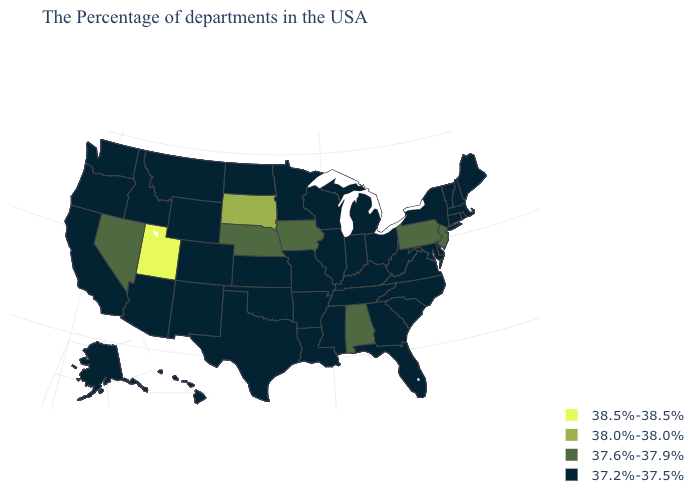Name the states that have a value in the range 37.6%-37.9%?
Be succinct. New Jersey, Pennsylvania, Alabama, Iowa, Nebraska, Nevada. What is the value of Florida?
Keep it brief. 37.2%-37.5%. Among the states that border Minnesota , which have the highest value?
Give a very brief answer. South Dakota. What is the lowest value in the MidWest?
Answer briefly. 37.2%-37.5%. Name the states that have a value in the range 37.2%-37.5%?
Write a very short answer. Maine, Massachusetts, Rhode Island, New Hampshire, Vermont, Connecticut, New York, Delaware, Maryland, Virginia, North Carolina, South Carolina, West Virginia, Ohio, Florida, Georgia, Michigan, Kentucky, Indiana, Tennessee, Wisconsin, Illinois, Mississippi, Louisiana, Missouri, Arkansas, Minnesota, Kansas, Oklahoma, Texas, North Dakota, Wyoming, Colorado, New Mexico, Montana, Arizona, Idaho, California, Washington, Oregon, Alaska, Hawaii. What is the lowest value in the Northeast?
Quick response, please. 37.2%-37.5%. Does Texas have a higher value than Vermont?
Concise answer only. No. Does Wisconsin have the highest value in the USA?
Keep it brief. No. Among the states that border Alabama , which have the highest value?
Short answer required. Florida, Georgia, Tennessee, Mississippi. Among the states that border Maine , which have the highest value?
Answer briefly. New Hampshire. What is the value of Washington?
Write a very short answer. 37.2%-37.5%. Name the states that have a value in the range 38.0%-38.0%?
Answer briefly. South Dakota. What is the value of New Hampshire?
Answer briefly. 37.2%-37.5%. What is the value of Montana?
Keep it brief. 37.2%-37.5%. Is the legend a continuous bar?
Quick response, please. No. 